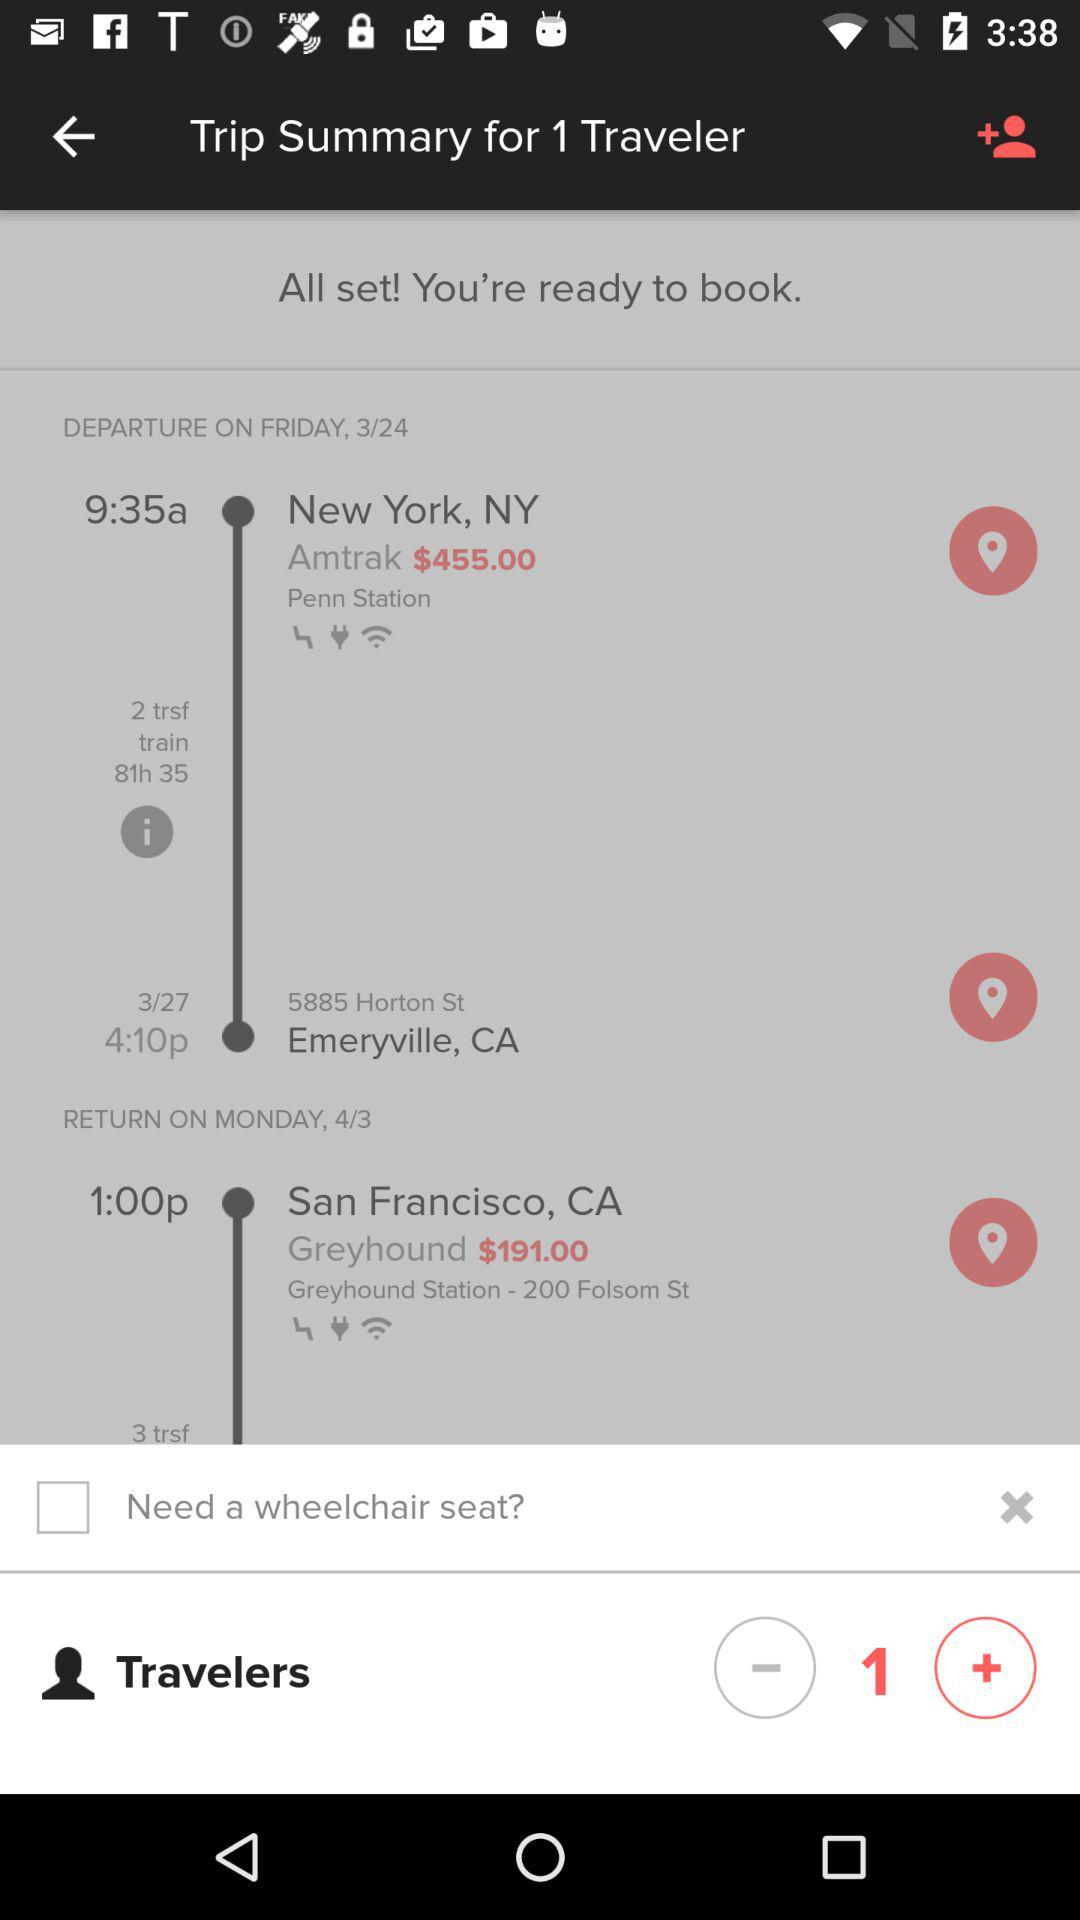What is the fare charge given for Greyhound, San Francisco, CA? The fare charge is $191.00. 